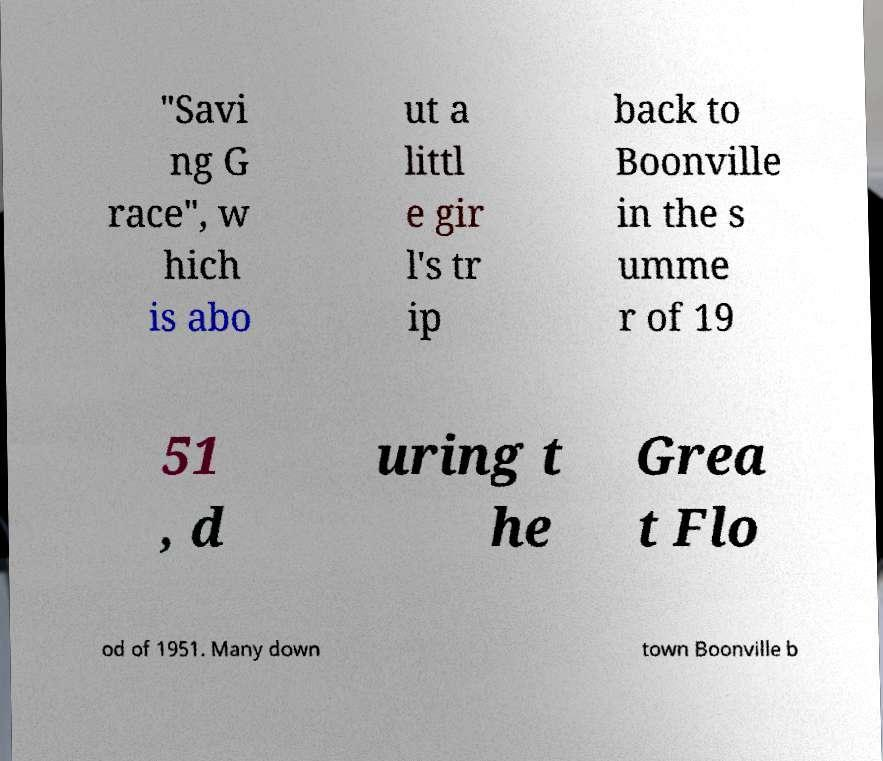Please identify and transcribe the text found in this image. "Savi ng G race", w hich is abo ut a littl e gir l's tr ip back to Boonville in the s umme r of 19 51 , d uring t he Grea t Flo od of 1951. Many down town Boonville b 